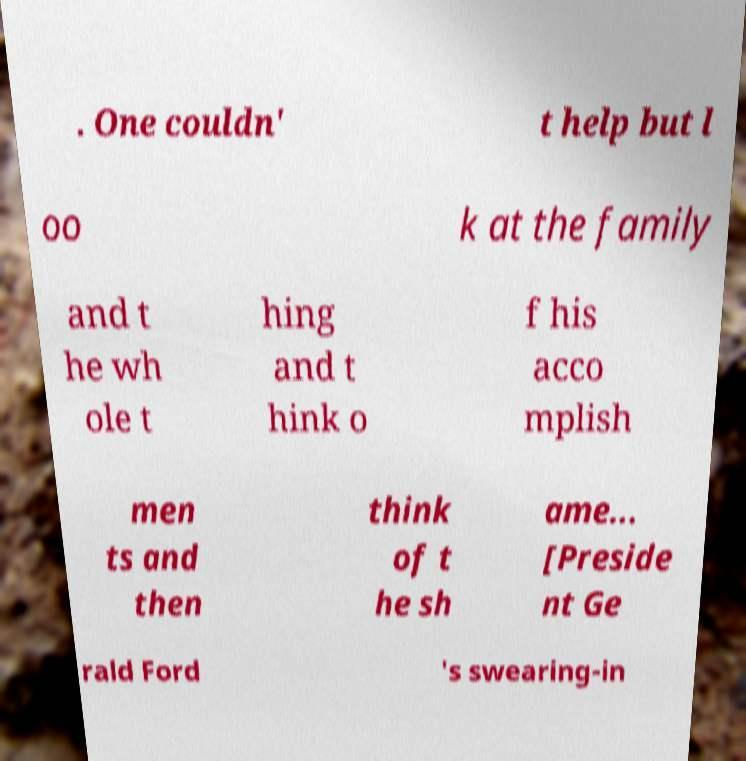Please read and relay the text visible in this image. What does it say? . One couldn' t help but l oo k at the family and t he wh ole t hing and t hink o f his acco mplish men ts and then think of t he sh ame... [Preside nt Ge rald Ford 's swearing-in 